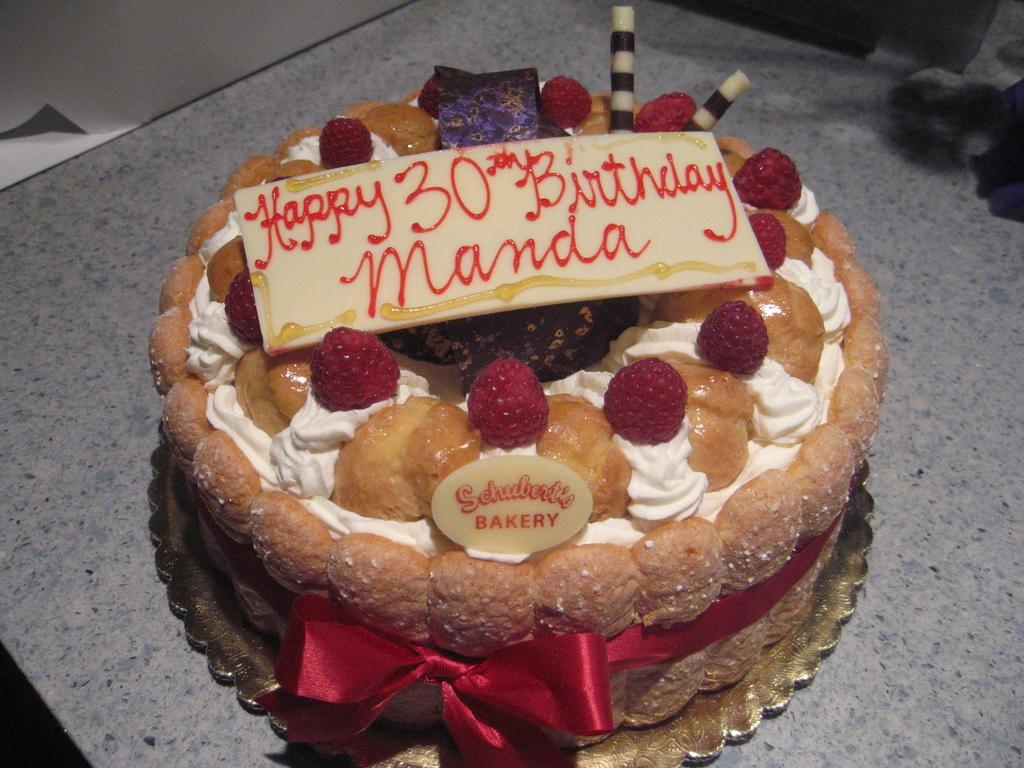What is on the table in the image? There is a cake on the table. What decorations are on the cake? There are fruits on the cake. How is the cake adorned or held together? The cake is tied with a ribbon. What channel is the cake tuned to in the image? The cake is not a television or device that can be tuned to a channel; it is a dessert with fruits and a ribbon. 